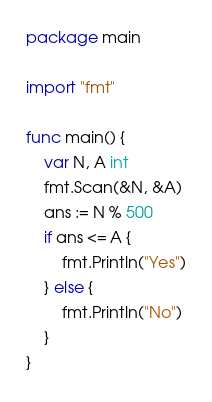Convert code to text. <code><loc_0><loc_0><loc_500><loc_500><_Go_>package main

import "fmt"

func main() {
	var N, A int
	fmt.Scan(&N, &A)
	ans := N % 500
	if ans <= A {
		fmt.Println("Yes")
	} else {
		fmt.Println("No")
	}
}
</code> 